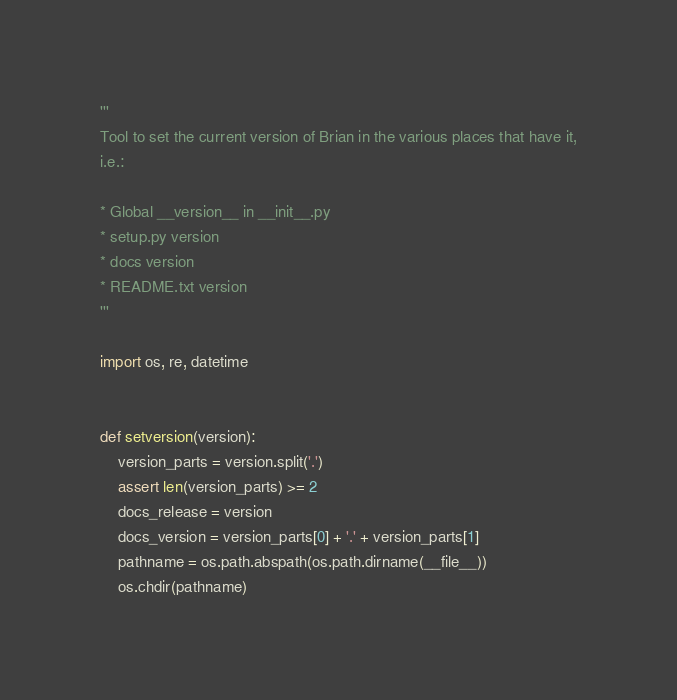Convert code to text. <code><loc_0><loc_0><loc_500><loc_500><_Python_>'''
Tool to set the current version of Brian in the various places that have it,
i.e.:

* Global __version__ in __init__.py
* setup.py version
* docs version
* README.txt version
'''

import os, re, datetime


def setversion(version):
    version_parts = version.split('.')
    assert len(version_parts) >= 2
    docs_release = version
    docs_version = version_parts[0] + '.' + version_parts[1]
    pathname = os.path.abspath(os.path.dirname(__file__))
    os.chdir(pathname)</code> 